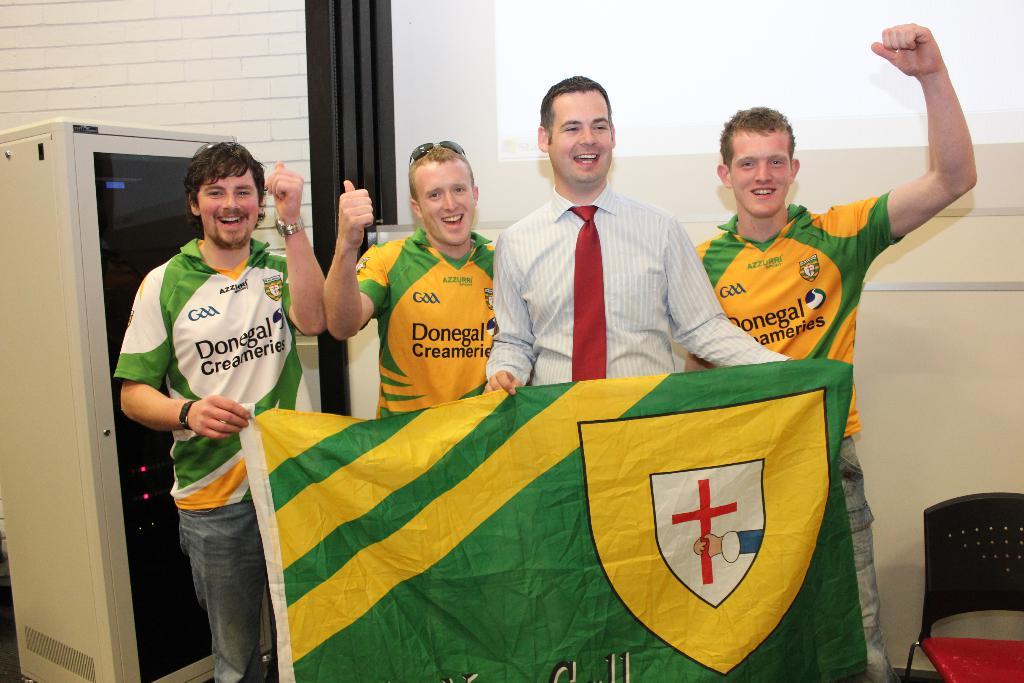What team do these people play for?
Offer a terse response. Donegal. What is written below the neck of the players?
Offer a very short reply. Azzurri. 